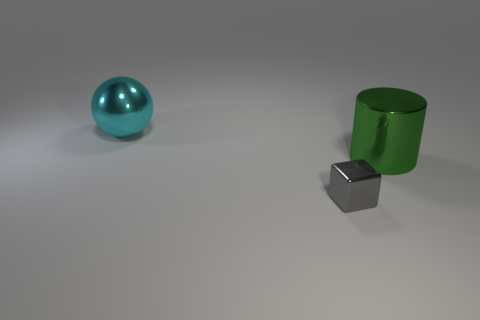There is a big metal thing that is on the right side of the metallic thing that is to the left of the small shiny cube; what shape is it?
Make the answer very short. Cylinder. What number of gray objects are either small cubes or spheres?
Keep it short and to the point. 1. What color is the metallic block?
Provide a succinct answer. Gray. Is the cylinder the same size as the gray thing?
Your answer should be very brief. No. Is there any other thing that has the same shape as the small gray thing?
Provide a succinct answer. No. Is the material of the cyan sphere the same as the thing that is to the right of the tiny block?
Provide a succinct answer. Yes. There is a large thing on the left side of the small gray metallic thing; is its color the same as the cylinder?
Make the answer very short. No. How many big shiny things are both on the right side of the tiny metallic block and behind the large green object?
Offer a terse response. 0. How many other objects are the same material as the small block?
Your answer should be very brief. 2. Are the object that is on the right side of the cube and the big cyan thing made of the same material?
Your answer should be very brief. Yes. 